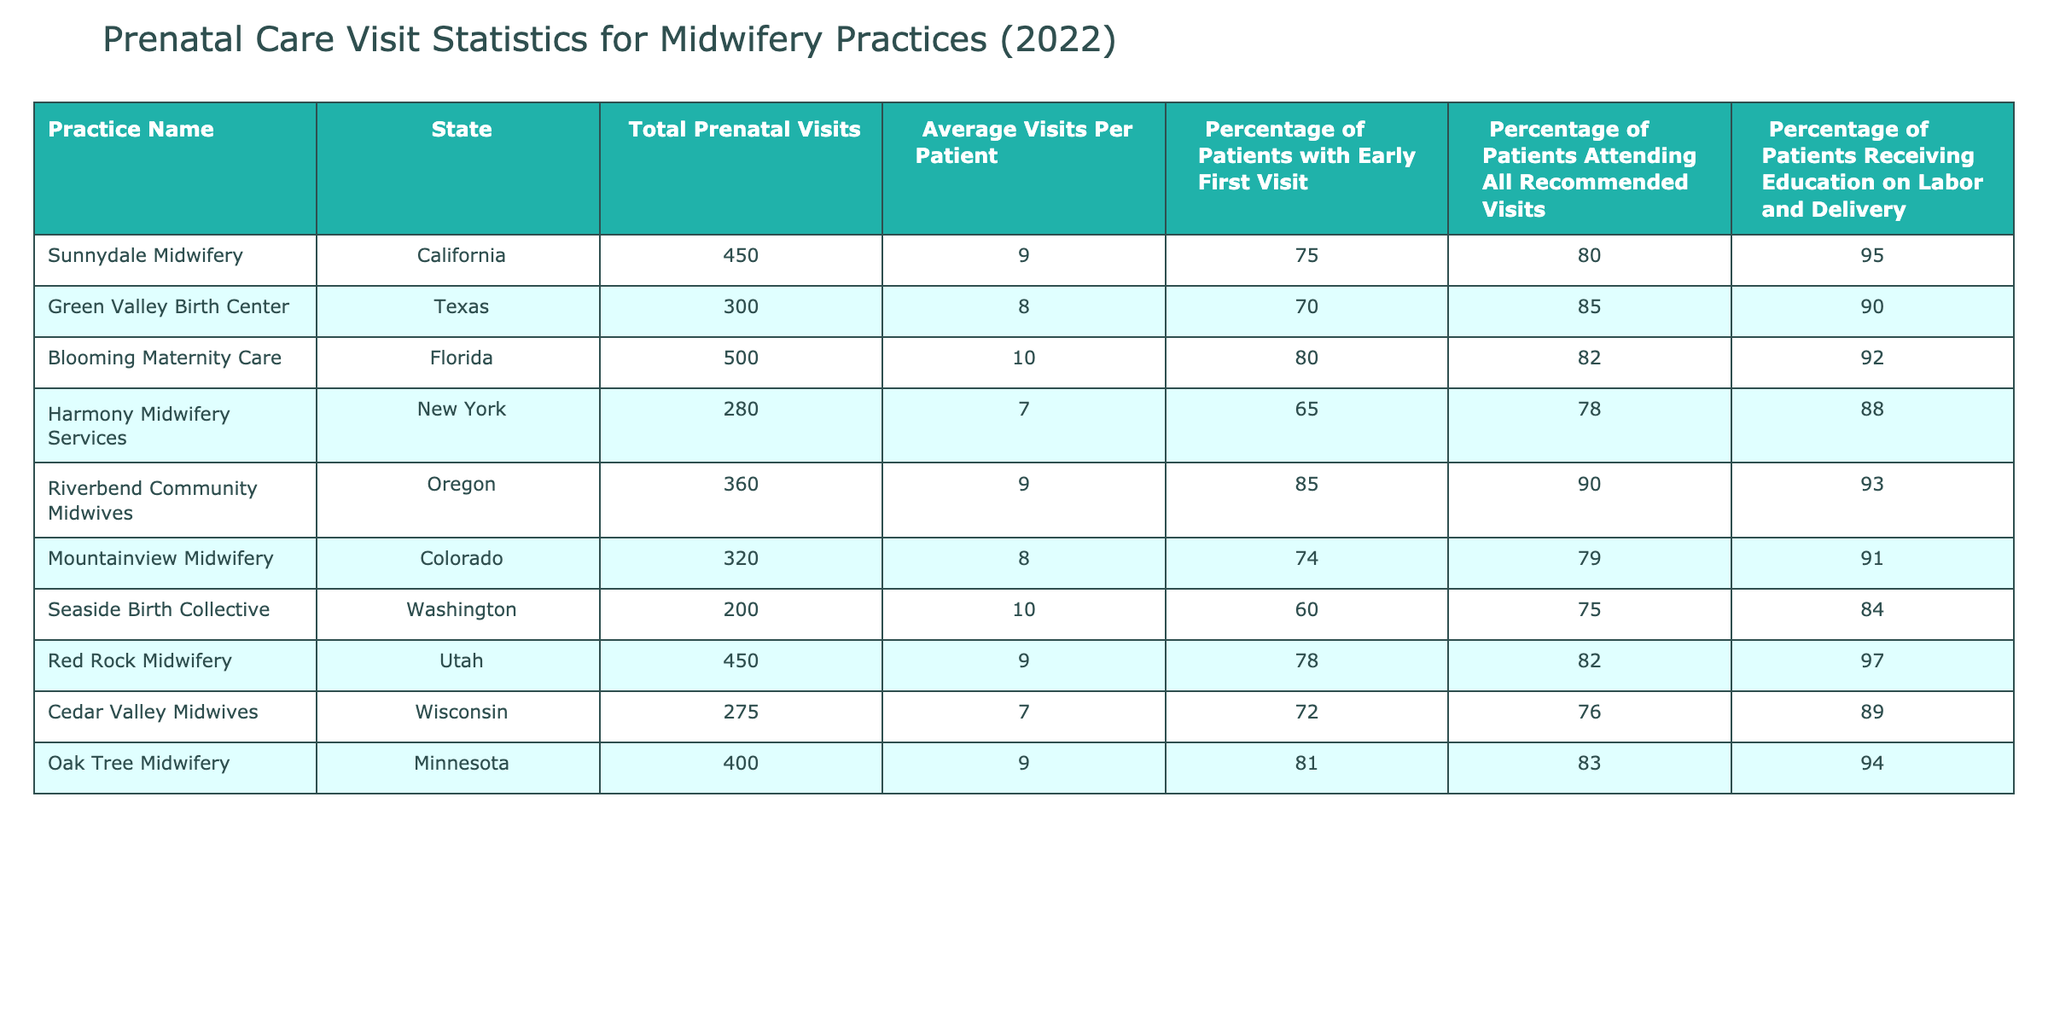What is the total number of prenatal visits at Blooming Maternity Care? The table shows the total prenatal visits for Blooming Maternity Care listed under the "Total Prenatal Visits" column. The value is clearly marked as 500.
Answer: 500 Which midwifery practice had the highest average visits per patient? By examining the "Average Visits Per Patient" column, we see that Blooming Maternity Care has the highest value of 10.
Answer: Blooming Maternity Care Did Cedar Valley Midwives have more than 70% of patients attending all recommended visits? Checking the "Percentage of Patients Attending All Recommended Visits" column, Cedar Valley Midwives is listed with 76%, which is greater than 70%.
Answer: Yes What is the difference in the percentage of patients with early first visits between Riverbend Community Midwives and Harmony Midwifery Services? Riverbend Community Midwives has 85%, and Harmony Midwifery Services has 65%. The difference is calculated as 85 - 65 = 20%.
Answer: 20% How many practices had an average visits per patient that was equal to or greater than 9? Count the number of practices where the "Average Visits Per Patient" is equal to or greater than 9. These practices are Sunnydale Midwifery, Blooming Maternity Care, Riverbend Community Midwives, Red Rock Midwifery, and Oak Tree Midwifery, totaling 5 practices.
Answer: 5 Which state has the highest percentage of patients receiving education on labor and delivery? Looking at the "Percentage of Patients Receiving Education on Labor and Delivery" column, Red Rock Midwifery has the highest percentage of 97%.
Answer: Utah 